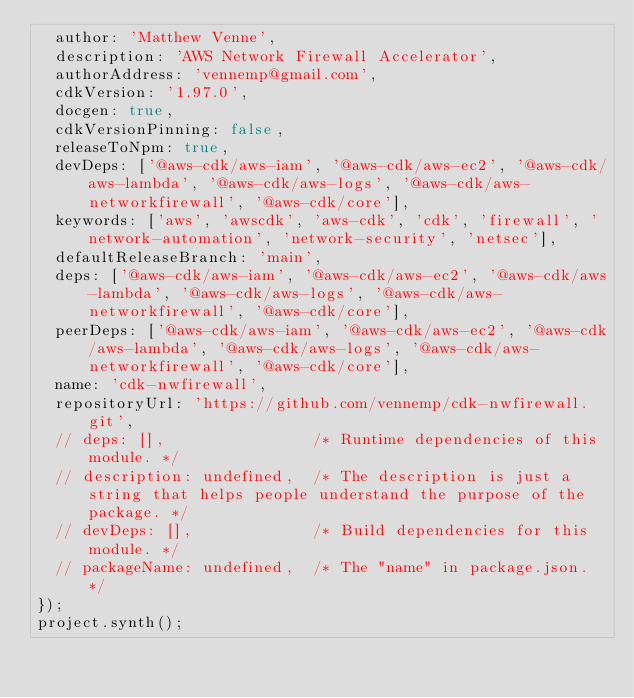<code> <loc_0><loc_0><loc_500><loc_500><_JavaScript_>  author: 'Matthew Venne',
  description: 'AWS Network Firewall Accelerator',
  authorAddress: 'vennemp@gmail.com',
  cdkVersion: '1.97.0',
  docgen: true,
  cdkVersionPinning: false,
  releaseToNpm: true,
  devDeps: ['@aws-cdk/aws-iam', '@aws-cdk/aws-ec2', '@aws-cdk/aws-lambda', '@aws-cdk/aws-logs', '@aws-cdk/aws-networkfirewall', '@aws-cdk/core'],
  keywords: ['aws', 'awscdk', 'aws-cdk', 'cdk', 'firewall', 'network-automation', 'network-security', 'netsec'],
  defaultReleaseBranch: 'main',
  deps: ['@aws-cdk/aws-iam', '@aws-cdk/aws-ec2', '@aws-cdk/aws-lambda', '@aws-cdk/aws-logs', '@aws-cdk/aws-networkfirewall', '@aws-cdk/core'],
  peerDeps: ['@aws-cdk/aws-iam', '@aws-cdk/aws-ec2', '@aws-cdk/aws-lambda', '@aws-cdk/aws-logs', '@aws-cdk/aws-networkfirewall', '@aws-cdk/core'],
  name: 'cdk-nwfirewall',
  repositoryUrl: 'https://github.com/vennemp/cdk-nwfirewall.git',
  // deps: [],                /* Runtime dependencies of this module. */
  // description: undefined,  /* The description is just a string that helps people understand the purpose of the package. */
  // devDeps: [],             /* Build dependencies for this module. */
  // packageName: undefined,  /* The "name" in package.json. */
});
project.synth();
</code> 